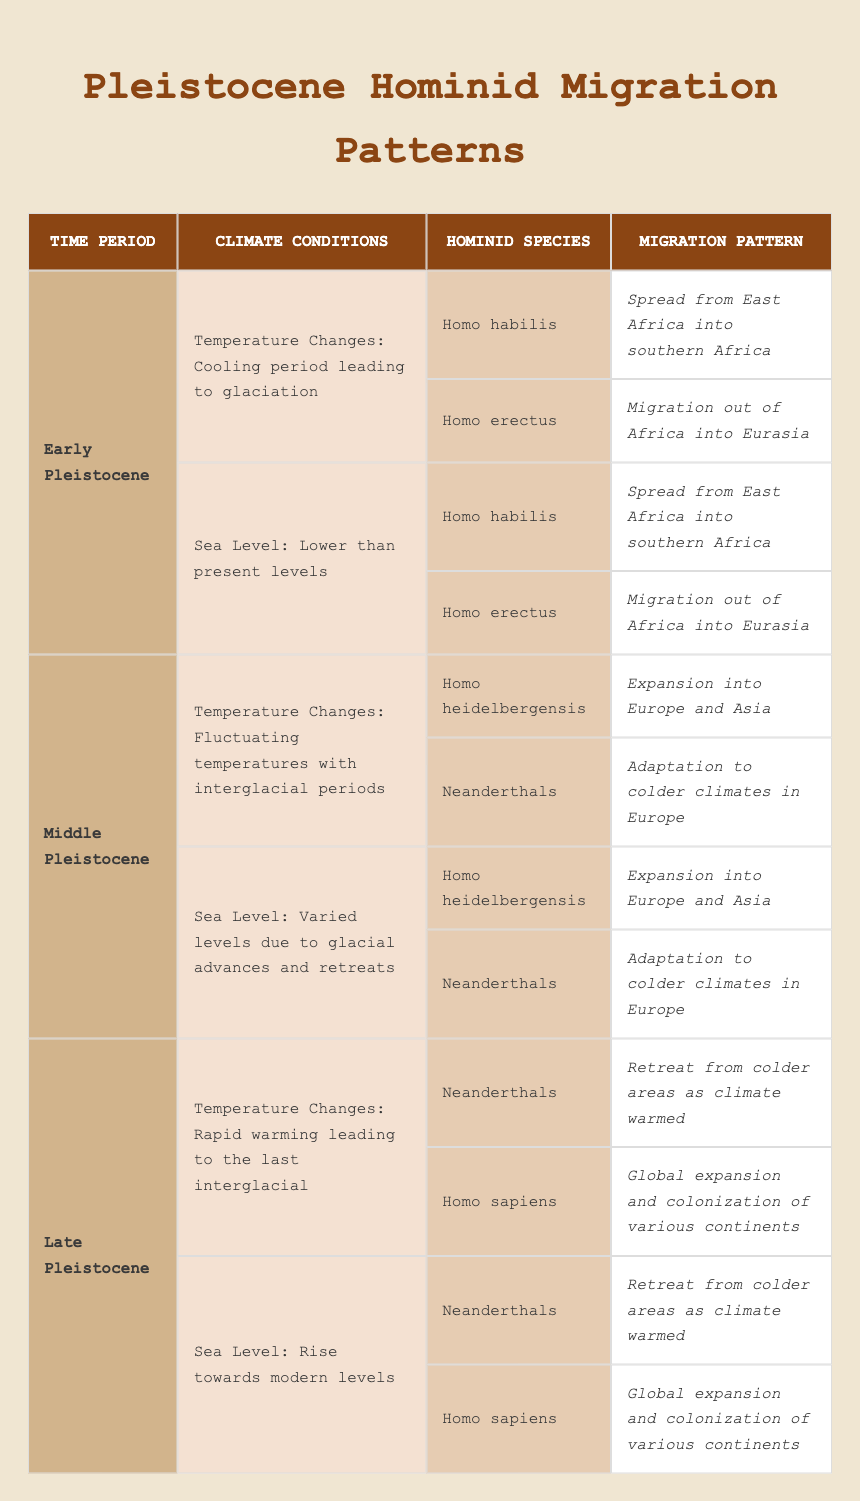What were the climate conditions during the Early Pleistocene? The table specifies the temperature changes were characterized by a cooling period leading to glaciation and that the sea level was lower than present levels during the Early Pleistocene.
Answer: Cooling period leading to glaciation; Lower than present levels Which hominid species migrated out of Africa during the Early Pleistocene? According to the table, the hominid species that migrated out of Africa during the Early Pleistocene was Homo erectus as indicated in its migration pattern.
Answer: Homo erectus Did Neanderthals expand into Africa during the Middle Pleistocene? Referring to the information in the table, Neanderthals adapted to colder climates in Europe and there is no mention of them expanding into Africa. Therefore, the statement is false.
Answer: No How many hominid species are listed for the Late Pleistocene? The table provides a total of two hominid species listed for the Late Pleistocene: Neanderthals and Homo sapiens. Thus, the total count is two.
Answer: Two What was the impact of climate change on Neanderthals during the Late Pleistocene? The table indicates that Neanderthals retreated from colder areas as the climate warmed, suggesting their migration patterns were directly influenced by climate change.
Answer: Retreated from colder areas What is the sea level condition during the Middle Pleistocene? The table states that the sea level during the Middle Pleistocene was varied due to glacial advances and retreats, indicating a non-static condition of the sea level.
Answer: Varied levels due to glacial advances and retreats How did Homo habilis' migration pattern differ from that of Homo sapiens during their respective time periods? Homo habilis spread from East Africa into southern Africa during the Early Pleistocene, while Homo sapiens had a global expansion and colonization of various continents during the Late Pleistocene. This reflects a difference in both geographical focus and temporal context of migration.
Answer: Homo habilis: spread from East Africa; Homo sapiens: global expansion What is the average number of hominid species migrating in each time period? There are 2 hominid species in Early Pleistocene, 2 in Middle Pleistocene, and 2 in Late Pleistocene. Summing them up gives us 6 species across the three periods (2 + 2 + 2 = 6), and dividing by the 3 time periods gives us an average of 2 species per period.
Answer: 2 species per period 